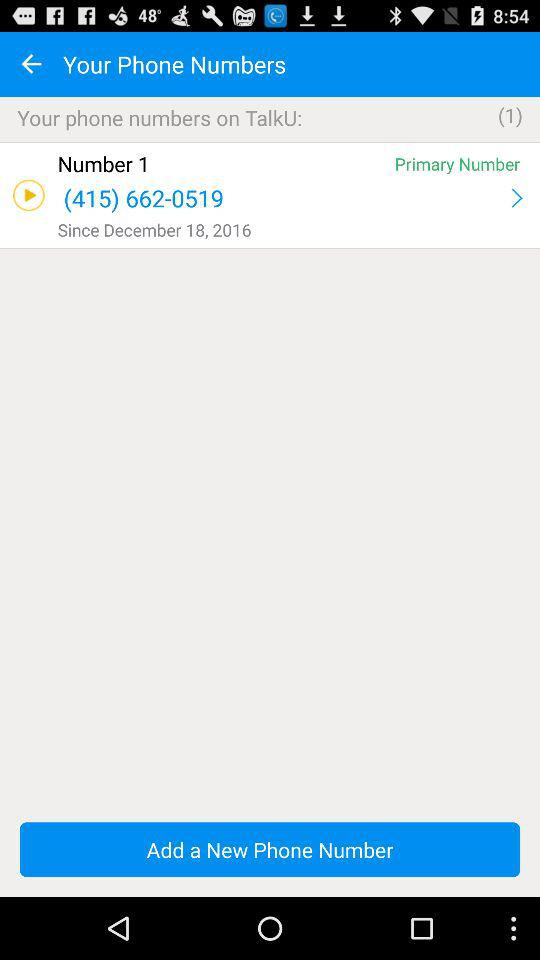In what year was the phone number saved? The phone number was saved in 2016. 